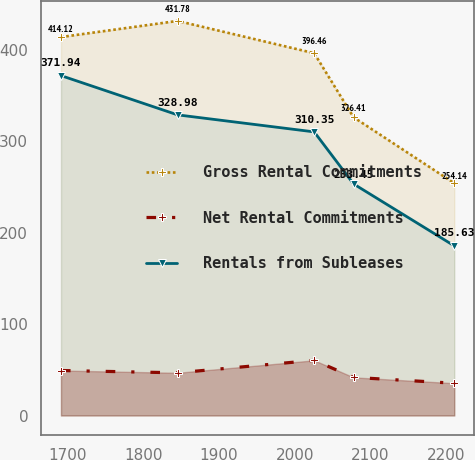Convert chart to OTSL. <chart><loc_0><loc_0><loc_500><loc_500><line_chart><ecel><fcel>Gross Rental Commitments<fcel>Net Rental Commitments<fcel>Rentals from Subleases<nl><fcel>1691.14<fcel>414.12<fcel>49.23<fcel>371.94<nl><fcel>1845.19<fcel>431.78<fcel>46.72<fcel>328.98<nl><fcel>2025.75<fcel>396.46<fcel>60.4<fcel>310.35<nl><fcel>2077.72<fcel>326.41<fcel>41.73<fcel>253.45<nl><fcel>2210.87<fcel>254.14<fcel>35.32<fcel>185.63<nl></chart> 